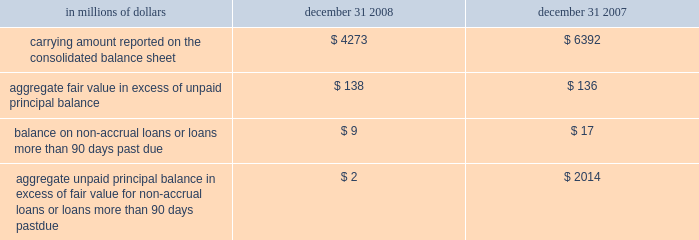The company has elected the fair-value option where the interest-rate risk of such liabilities is economically hedged with derivative contracts or the proceeds are used to purchase financial assets that will also be accounted for at fair value through earnings .
The election has been made to mitigate accounting mismatches and to achieve operational simplifications .
These positions are reported in short-term borrowings and long-term debt on the company 2019s consolidated balance sheet .
The majority of these non-structured liabilities are a result of the company 2019s election of the fair-value option for liabilities associated with the citi-advised structured investment vehicles ( sivs ) , which were consolidated during the fourth quarter of 2007 .
The change in fair values of the sivs 2019 liabilities reported in earnings was $ 2.6 billion for the year ended december 31 , 2008 .
For these non-structured liabilities the aggregate fair value is $ 263 million lower than the aggregate unpaid principal balance as of december 31 , 2008 .
For all other non-structured liabilities classified as long-term debt for which the fair-value option has been elected , the aggregate unpaid principal balance exceeds the aggregate fair value of such instruments by $ 97 million as of december 31 , 2008 while the aggregate fair value exceeded the aggregate unpaid principal by $ 112 million as of december 31 , 2007 .
The change in fair value of these non-structured liabilities reported a gain of $ 1.2 billion for the year ended december 31 , 2008 .
The change in fair value for these non-structured liabilities is reported in principal transactions in the company 2019s consolidated statement of income .
Related interest expense continues to be measured based on the contractual interest rates and reported as such in the consolidated income statement .
Certain mortgage loans citigroup has elected the fair-value option for certain purchased and originated prime fixed-rate and conforming adjustable-rate first mortgage loans held-for- sale .
These loans are intended for sale or securitization and are hedged with derivative instruments .
The company has elected the fair-value option to mitigate accounting mismatches in cases where hedge accounting is complex and to achieve operational simplifications .
The fair-value option was not elected for loans held-for-investment , as those loans are not hedged with derivative instruments .
This election was effective for applicable instruments originated or purchased on or after september 1 , 2007 .
The table provides information about certain mortgage loans carried at fair value : in millions of dollars december 31 , december 31 , carrying amount reported on the consolidated balance sheet $ 4273 $ 6392 aggregate fair value in excess of unpaid principal balance $ 138 $ 136 balance on non-accrual loans or loans more than 90 days past due $ 9 $ 17 aggregate unpaid principal balance in excess of fair value for non-accrual loans or loans more than 90 days past due $ 2 $ 2014 the changes in fair values of these mortgage loans is reported in other revenue in the company 2019s consolidated statement of income .
The changes in fair value during the year ended december 31 , 2008 due to instrument- specific credit risk resulted in a $ 32 million loss .
The change in fair value during 2007 due to instrument-specific credit risk was immaterial .
Related interest income continues to be measured based on the contractual interest rates and reported as such in the consolidated income statement .
Items selected for fair-value accounting in accordance with sfas 155 and sfas 156 certain hybrid financial instruments the company has elected to apply fair-value accounting under sfas 155 for certain hybrid financial assets and liabilities whose performance is linked to risks other than interest rate , foreign exchange or inflation ( e.g. , equity , credit or commodity risks ) .
In addition , the company has elected fair-value accounting under sfas 155 for residual interests retained from securitizing certain financial assets .
The company has elected fair-value accounting for these instruments because these exposures are considered to be trading-related positions and , therefore , are managed on a fair-value basis .
In addition , the accounting for these instruments is simplified under a fair-value approach as it eliminates the complicated operational requirements of bifurcating the embedded derivatives from the host contracts and accounting for each separately .
The hybrid financial instruments are classified as trading account assets , loans , deposits , trading account liabilities ( for prepaid derivatives ) , short-term borrowings or long-term debt on the company 2019s consolidated balance sheet according to their legal form , while residual interests in certain securitizations are classified as trading account assets .
For hybrid financial instruments for which fair-value accounting has been elected under sfas 155 and that are classified as long-term debt , the aggregate unpaid principal exceeds the aggregate fair value by $ 1.9 billion as of december 31 , 2008 , while the aggregate fair value exceeds the aggregate unpaid principal balance by $ 460 million as of december 31 , 2007 .
The difference for those instruments classified as loans is immaterial .
Changes in fair value for hybrid financial instruments , which in most cases includes a component for accrued interest , are recorded in principal transactions in the company 2019s consolidated statement of income .
Interest accruals for certain hybrid instruments classified as trading assets are recorded separately from the change in fair value as interest revenue in the company 2019s consolidated statement of income .
Mortgage servicing rights the company accounts for mortgage servicing rights ( msrs ) at fair value in accordance with sfas 156 .
Fair value for msrs is determined using an option-adjusted spread valuation approach .
This approach consists of projecting servicing cash flows under multiple interest-rate scenarios and discounting these cash flows using risk-adjusted rates .
The model assumptions used in the valuation of msrs include mortgage prepayment speeds and discount rates .
The fair value of msrs is primarily affected by changes in prepayments that result from shifts in mortgage interest rates .
In managing this risk , the company hedges a significant portion of the values of its msrs through the use of interest-rate derivative contracts , forward- purchase commitments of mortgage-backed securities , and purchased securities classified as trading .
See note 23 on page 175 for further discussions regarding the accounting and reporting of msrs .
These msrs , which totaled $ 5.7 billion and $ 8.4 billion as of december 31 , 2008 and december 31 , 2007 , respectively , are classified as mortgage servicing rights on citigroup 2019s consolidated balance sheet .
Changes in fair value of msrs are recorded in commissions and fees in the company 2019s consolidated statement of income. .
The company has elected the fair-value option where the interest-rate risk of such liabilities is economically hedged with derivative contracts or the proceeds are used to purchase financial assets that will also be accounted for at fair value through earnings .
The election has been made to mitigate accounting mismatches and to achieve operational simplifications .
These positions are reported in short-term borrowings and long-term debt on the company 2019s consolidated balance sheet .
The majority of these non-structured liabilities are a result of the company 2019s election of the fair-value option for liabilities associated with the citi-advised structured investment vehicles ( sivs ) , which were consolidated during the fourth quarter of 2007 .
The change in fair values of the sivs 2019 liabilities reported in earnings was $ 2.6 billion for the year ended december 31 , 2008 .
For these non-structured liabilities the aggregate fair value is $ 263 million lower than the aggregate unpaid principal balance as of december 31 , 2008 .
For all other non-structured liabilities classified as long-term debt for which the fair-value option has been elected , the aggregate unpaid principal balance exceeds the aggregate fair value of such instruments by $ 97 million as of december 31 , 2008 while the aggregate fair value exceeded the aggregate unpaid principal by $ 112 million as of december 31 , 2007 .
The change in fair value of these non-structured liabilities reported a gain of $ 1.2 billion for the year ended december 31 , 2008 .
The change in fair value for these non-structured liabilities is reported in principal transactions in the company 2019s consolidated statement of income .
Related interest expense continues to be measured based on the contractual interest rates and reported as such in the consolidated income statement .
Certain mortgage loans citigroup has elected the fair-value option for certain purchased and originated prime fixed-rate and conforming adjustable-rate first mortgage loans held-for- sale .
These loans are intended for sale or securitization and are hedged with derivative instruments .
The company has elected the fair-value option to mitigate accounting mismatches in cases where hedge accounting is complex and to achieve operational simplifications .
The fair-value option was not elected for loans held-for-investment , as those loans are not hedged with derivative instruments .
This election was effective for applicable instruments originated or purchased on or after september 1 , 2007 .
The following table provides information about certain mortgage loans carried at fair value : in millions of dollars december 31 , december 31 , carrying amount reported on the consolidated balance sheet $ 4273 $ 6392 aggregate fair value in excess of unpaid principal balance $ 138 $ 136 balance on non-accrual loans or loans more than 90 days past due $ 9 $ 17 aggregate unpaid principal balance in excess of fair value for non-accrual loans or loans more than 90 days past due $ 2 $ 2014 the changes in fair values of these mortgage loans is reported in other revenue in the company 2019s consolidated statement of income .
The changes in fair value during the year ended december 31 , 2008 due to instrument- specific credit risk resulted in a $ 32 million loss .
The change in fair value during 2007 due to instrument-specific credit risk was immaterial .
Related interest income continues to be measured based on the contractual interest rates and reported as such in the consolidated income statement .
Items selected for fair-value accounting in accordance with sfas 155 and sfas 156 certain hybrid financial instruments the company has elected to apply fair-value accounting under sfas 155 for certain hybrid financial assets and liabilities whose performance is linked to risks other than interest rate , foreign exchange or inflation ( e.g. , equity , credit or commodity risks ) .
In addition , the company has elected fair-value accounting under sfas 155 for residual interests retained from securitizing certain financial assets .
The company has elected fair-value accounting for these instruments because these exposures are considered to be trading-related positions and , therefore , are managed on a fair-value basis .
In addition , the accounting for these instruments is simplified under a fair-value approach as it eliminates the complicated operational requirements of bifurcating the embedded derivatives from the host contracts and accounting for each separately .
The hybrid financial instruments are classified as trading account assets , loans , deposits , trading account liabilities ( for prepaid derivatives ) , short-term borrowings or long-term debt on the company 2019s consolidated balance sheet according to their legal form , while residual interests in certain securitizations are classified as trading account assets .
For hybrid financial instruments for which fair-value accounting has been elected under sfas 155 and that are classified as long-term debt , the aggregate unpaid principal exceeds the aggregate fair value by $ 1.9 billion as of december 31 , 2008 , while the aggregate fair value exceeds the aggregate unpaid principal balance by $ 460 million as of december 31 , 2007 .
The difference for those instruments classified as loans is immaterial .
Changes in fair value for hybrid financial instruments , which in most cases includes a component for accrued interest , are recorded in principal transactions in the company 2019s consolidated statement of income .
Interest accruals for certain hybrid instruments classified as trading assets are recorded separately from the change in fair value as interest revenue in the company 2019s consolidated statement of income .
Mortgage servicing rights the company accounts for mortgage servicing rights ( msrs ) at fair value in accordance with sfas 156 .
Fair value for msrs is determined using an option-adjusted spread valuation approach .
This approach consists of projecting servicing cash flows under multiple interest-rate scenarios and discounting these cash flows using risk-adjusted rates .
The model assumptions used in the valuation of msrs include mortgage prepayment speeds and discount rates .
The fair value of msrs is primarily affected by changes in prepayments that result from shifts in mortgage interest rates .
In managing this risk , the company hedges a significant portion of the values of its msrs through the use of interest-rate derivative contracts , forward- purchase commitments of mortgage-backed securities , and purchased securities classified as trading .
See note 23 on page 175 for further discussions regarding the accounting and reporting of msrs .
These msrs , which totaled $ 5.7 billion and $ 8.4 billion as of december 31 , 2008 and december 31 , 2007 , respectively , are classified as mortgage servicing rights on citigroup 2019s consolidated balance sheet .
Changes in fair value of msrs are recorded in commissions and fees in the company 2019s consolidated statement of income. .
What was the percentage change in the fair value of the msr from 2007 to 2008? 
Computations: ((4273 - 6392) / 6392)
Answer: -0.33151. 